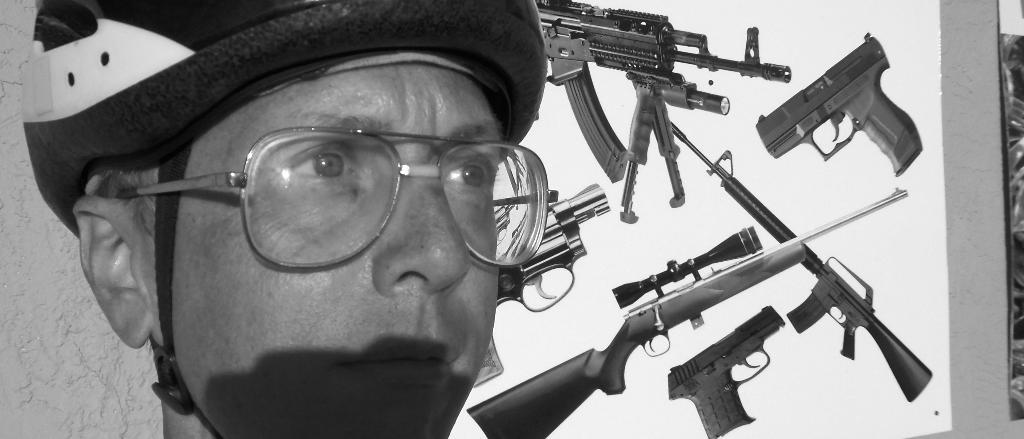Who is present in the image? There is a man in the image. What accessory is the man wearing? The man is wearing glasses (specs). What can be seen in the background of the image? There is a board in the background of the image. What is depicted on the board? The board has images on it. What type of waves can be seen crashing against the gate in the image? There are no waves or gates present in the image; it features a man wearing glasses and a board with images in the background. 